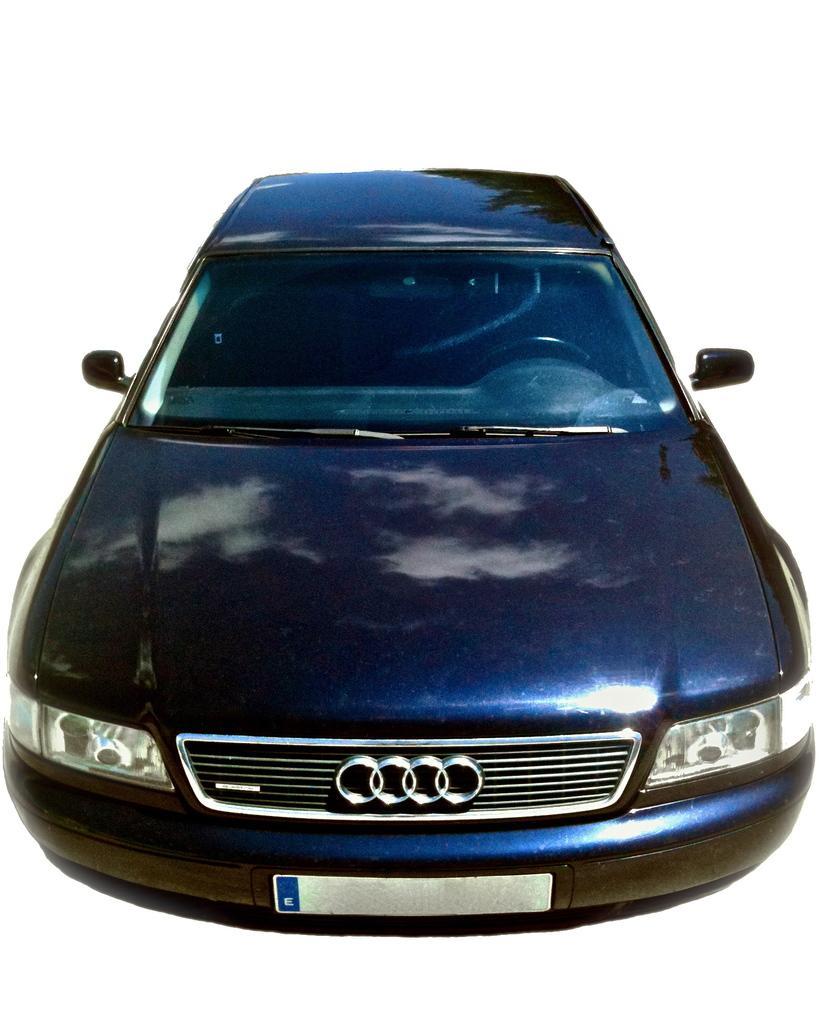How would you summarize this image in a sentence or two? In this image we can see a car with a vehicle registration plate and the background is white in color. 